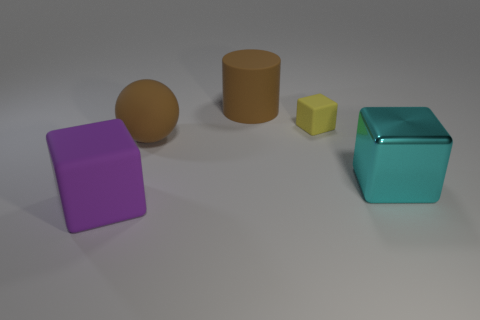Subtract all small yellow blocks. How many blocks are left? 2 Add 2 rubber things. How many objects exist? 7 Subtract 1 blocks. How many blocks are left? 2 Subtract all cyan cubes. How many cubes are left? 2 Subtract all cubes. How many objects are left? 2 Add 5 yellow blocks. How many yellow blocks are left? 6 Add 2 big purple objects. How many big purple objects exist? 3 Subtract 0 red blocks. How many objects are left? 5 Subtract all brown cubes. Subtract all yellow cylinders. How many cubes are left? 3 Subtract all purple blocks. Subtract all tiny green blocks. How many objects are left? 4 